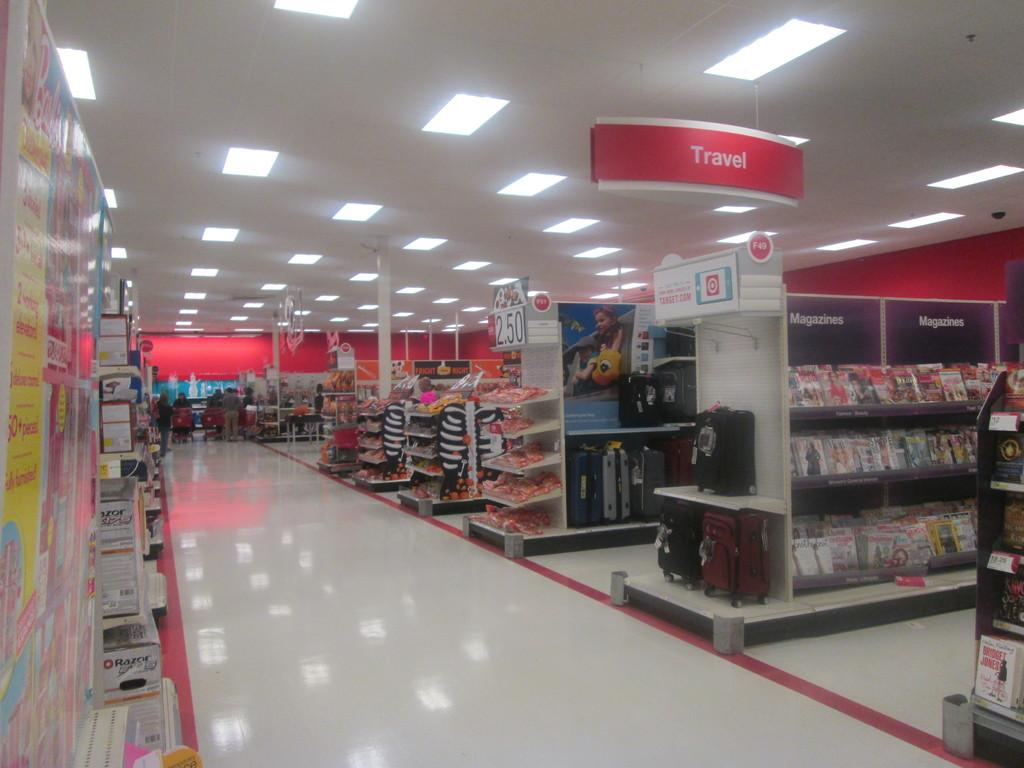<image>
Share a concise interpretation of the image provided. Travel section in a store that have a magazines section 